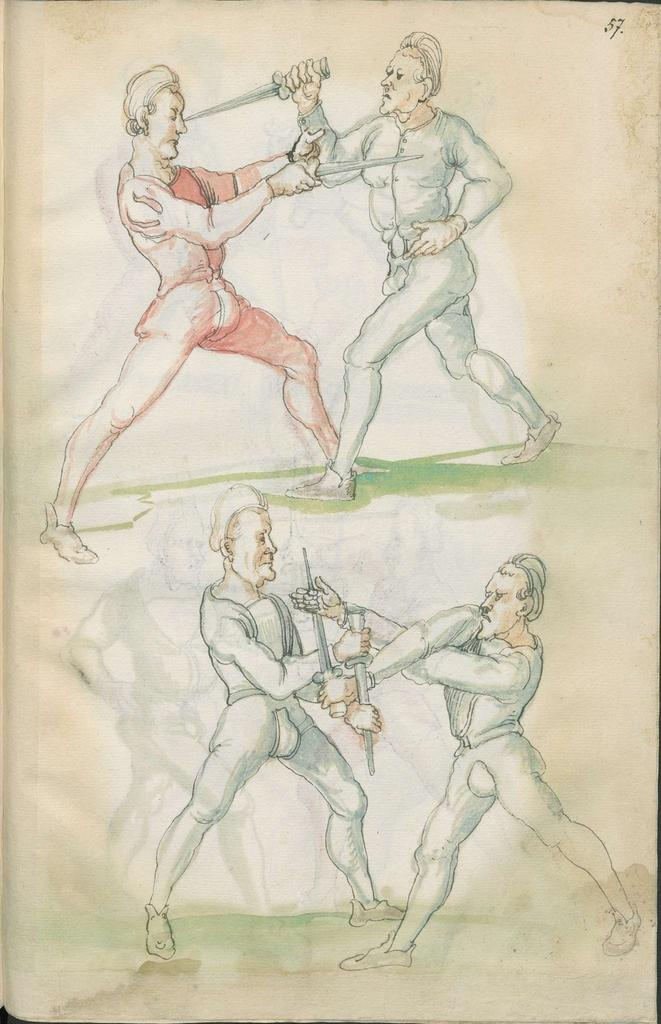What is the main subject of the image? There is a drawing in the image. What is happening in the drawing? The drawing depicts four people fighting each other. What are the people using in the drawing? The people are using swords in the drawing. What type of alarm can be heard going off in the drawing? There is no alarm present in the drawing; it is a static image depicting a fight between four people using swords. 